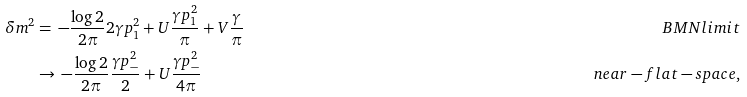Convert formula to latex. <formula><loc_0><loc_0><loc_500><loc_500>\quad \delta m ^ { 2 } & = \, - \frac { \log 2 } { 2 \pi } 2 \gamma p _ { 1 } ^ { 2 } + U \frac { \gamma p _ { 1 } ^ { 2 } } { \pi } + V \frac { \gamma } { \pi } & B M N l i m i t & \quad \\ & \to \, - \frac { \log 2 } { 2 \pi } \frac { \gamma p _ { - } ^ { 2 } } { 2 } + U \frac { \gamma p _ { - } ^ { 2 } } { 4 \pi } & n e a r - f l a t - s p a c e ,</formula> 